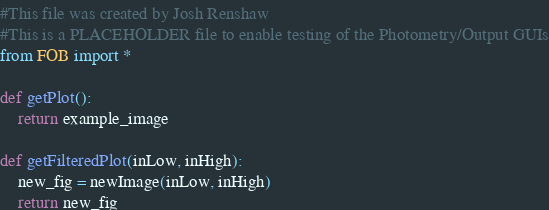Convert code to text. <code><loc_0><loc_0><loc_500><loc_500><_Python_>#This file was created by Josh Renshaw
#This is a PLACEHOLDER file to enable testing of the Photometry/Output GUIs
from FOB import *

def getPlot():
    return example_image

def getFilteredPlot(inLow, inHigh):
    new_fig = newImage(inLow, inHigh)
    return new_fig
</code> 